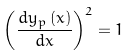Convert formula to latex. <formula><loc_0><loc_0><loc_500><loc_500>\left ( \frac { d y _ { p } \left ( x \right ) } { d x } \right ) ^ { 2 } = 1</formula> 